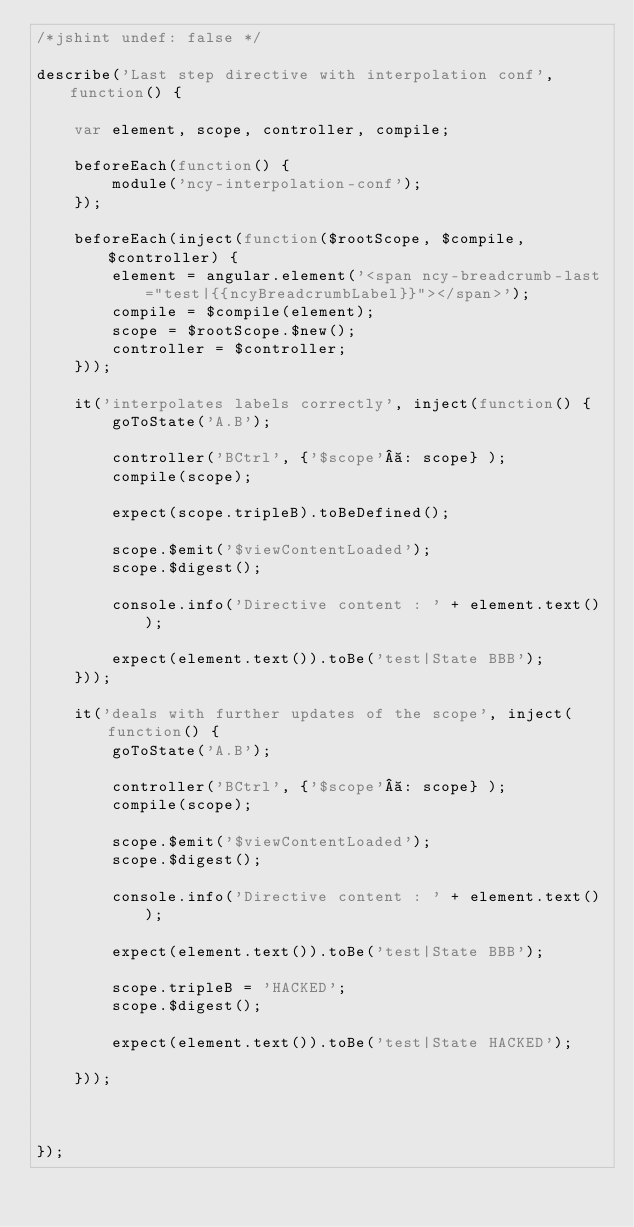Convert code to text. <code><loc_0><loc_0><loc_500><loc_500><_JavaScript_>/*jshint undef: false */

describe('Last step directive with interpolation conf', function() {

    var element, scope, controller, compile;

    beforeEach(function() {
        module('ncy-interpolation-conf');
    });

    beforeEach(inject(function($rootScope, $compile, $controller) {
        element = angular.element('<span ncy-breadcrumb-last="test|{{ncyBreadcrumbLabel}}"></span>');
        compile = $compile(element);
        scope = $rootScope.$new();
        controller = $controller;
    }));

    it('interpolates labels correctly', inject(function() {
        goToState('A.B');

        controller('BCtrl', {'$scope' : scope} );
        compile(scope);

        expect(scope.tripleB).toBeDefined();

        scope.$emit('$viewContentLoaded');
        scope.$digest();

        console.info('Directive content : ' + element.text());

        expect(element.text()).toBe('test|State BBB');
    }));

    it('deals with further updates of the scope', inject(function() {
        goToState('A.B');

        controller('BCtrl', {'$scope' : scope} );
        compile(scope);

        scope.$emit('$viewContentLoaded');
        scope.$digest();

        console.info('Directive content : ' + element.text());

        expect(element.text()).toBe('test|State BBB');

        scope.tripleB = 'HACKED';
        scope.$digest();

        expect(element.text()).toBe('test|State HACKED');

    }));



});
</code> 